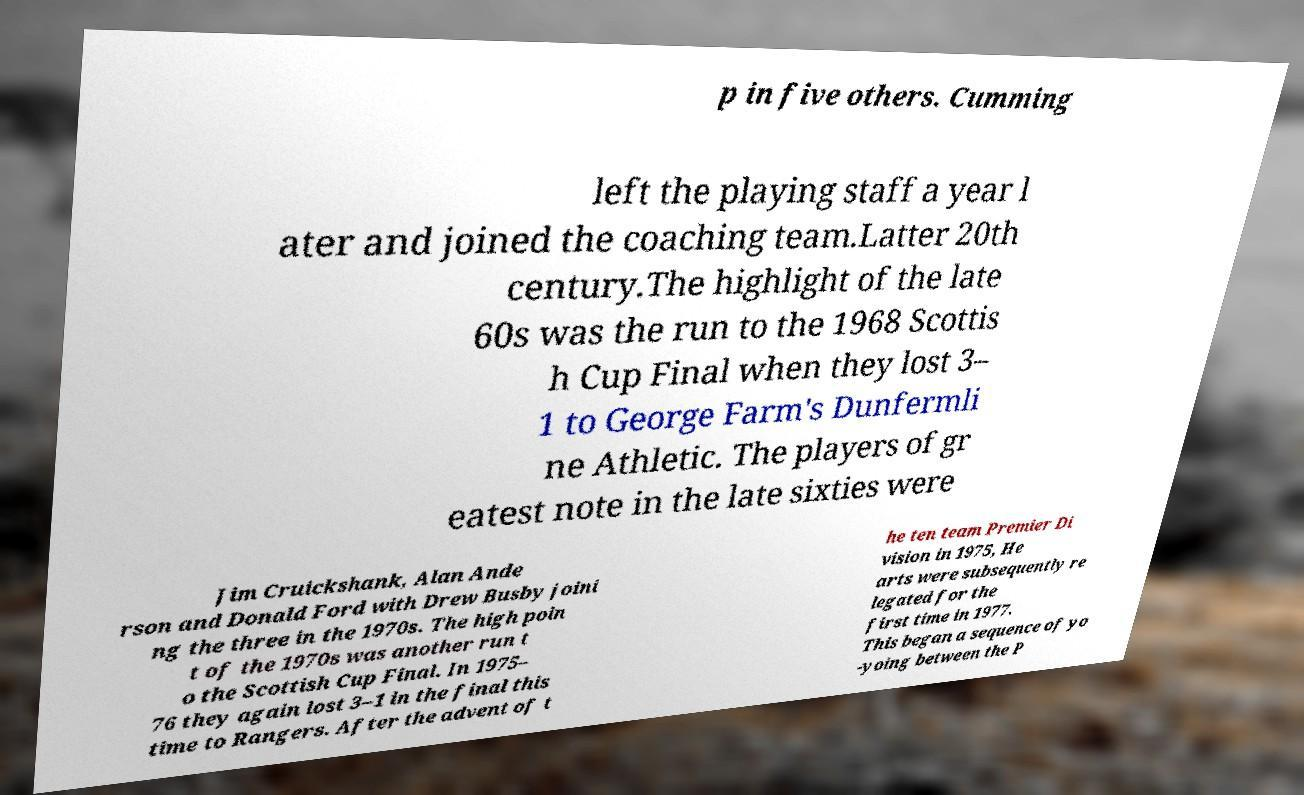What messages or text are displayed in this image? I need them in a readable, typed format. p in five others. Cumming left the playing staff a year l ater and joined the coaching team.Latter 20th century.The highlight of the late 60s was the run to the 1968 Scottis h Cup Final when they lost 3– 1 to George Farm's Dunfermli ne Athletic. The players of gr eatest note in the late sixties were Jim Cruickshank, Alan Ande rson and Donald Ford with Drew Busby joini ng the three in the 1970s. The high poin t of the 1970s was another run t o the Scottish Cup Final. In 1975– 76 they again lost 3–1 in the final this time to Rangers. After the advent of t he ten team Premier Di vision in 1975, He arts were subsequently re legated for the first time in 1977. This began a sequence of yo -yoing between the P 